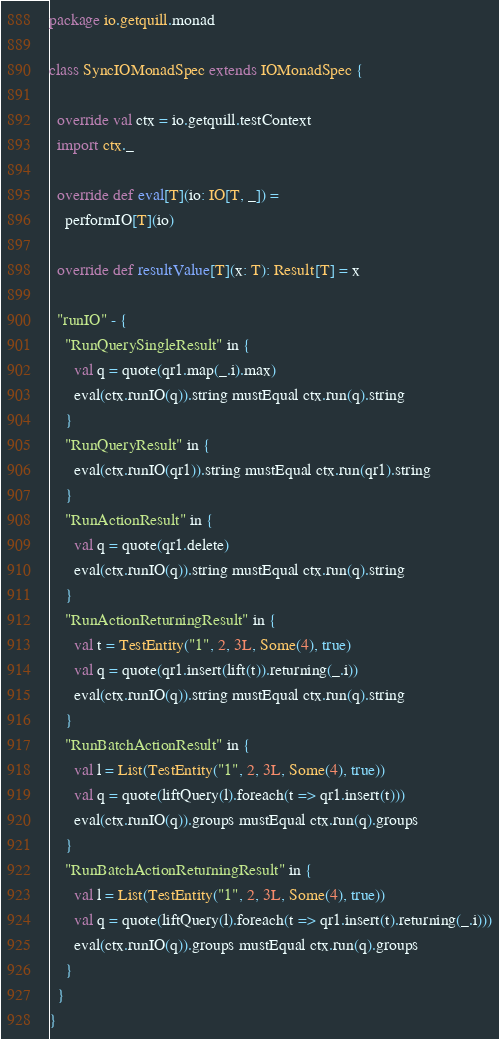<code> <loc_0><loc_0><loc_500><loc_500><_Scala_>package io.getquill.monad

class SyncIOMonadSpec extends IOMonadSpec {

  override val ctx = io.getquill.testContext
  import ctx._

  override def eval[T](io: IO[T, _]) =
    performIO[T](io)

  override def resultValue[T](x: T): Result[T] = x

  "runIO" - {
    "RunQuerySingleResult" in {
      val q = quote(qr1.map(_.i).max)
      eval(ctx.runIO(q)).string mustEqual ctx.run(q).string
    }
    "RunQueryResult" in {
      eval(ctx.runIO(qr1)).string mustEqual ctx.run(qr1).string
    }
    "RunActionResult" in {
      val q = quote(qr1.delete)
      eval(ctx.runIO(q)).string mustEqual ctx.run(q).string
    }
    "RunActionReturningResult" in {
      val t = TestEntity("1", 2, 3L, Some(4), true)
      val q = quote(qr1.insert(lift(t)).returning(_.i))
      eval(ctx.runIO(q)).string mustEqual ctx.run(q).string
    }
    "RunBatchActionResult" in {
      val l = List(TestEntity("1", 2, 3L, Some(4), true))
      val q = quote(liftQuery(l).foreach(t => qr1.insert(t)))
      eval(ctx.runIO(q)).groups mustEqual ctx.run(q).groups
    }
    "RunBatchActionReturningResult" in {
      val l = List(TestEntity("1", 2, 3L, Some(4), true))
      val q = quote(liftQuery(l).foreach(t => qr1.insert(t).returning(_.i)))
      eval(ctx.runIO(q)).groups mustEqual ctx.run(q).groups
    }
  }
}
</code> 